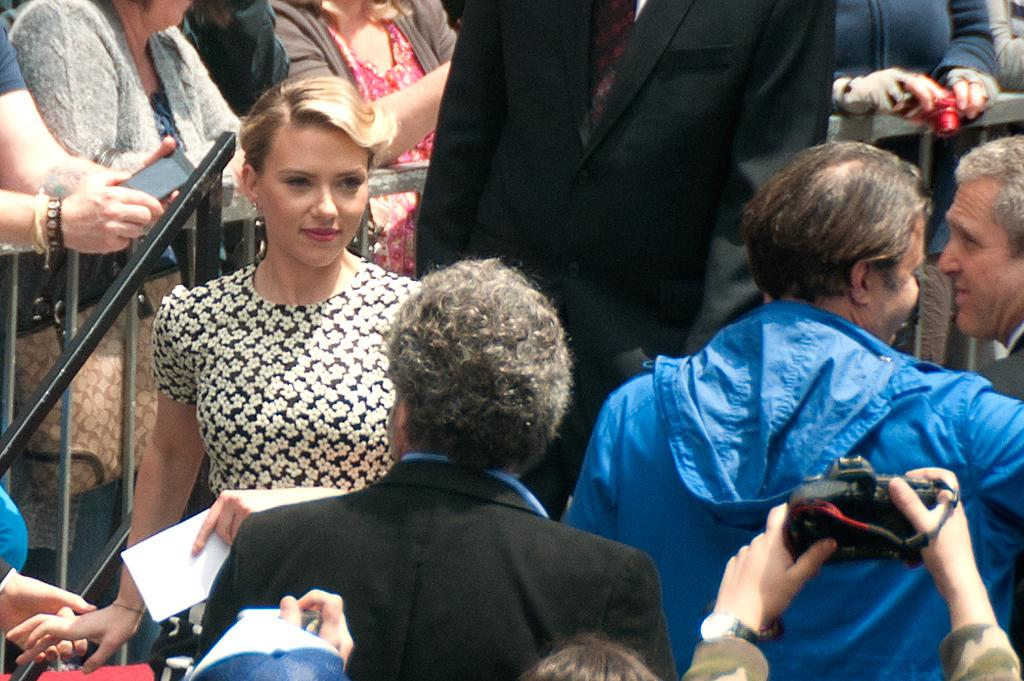How many people are present in the image? There are many people in the image. What are some of the people holding in their hands? Some people are holding objects in their hands. Can you describe the fence in the image? There is a fence visible from the left to the right side of the image. Where is the hill located in the image? There is no hill present in the image. What type of club is being used by the people in the image? There is no club present in the image; people are holding various objects, but none are identified as clubs. 